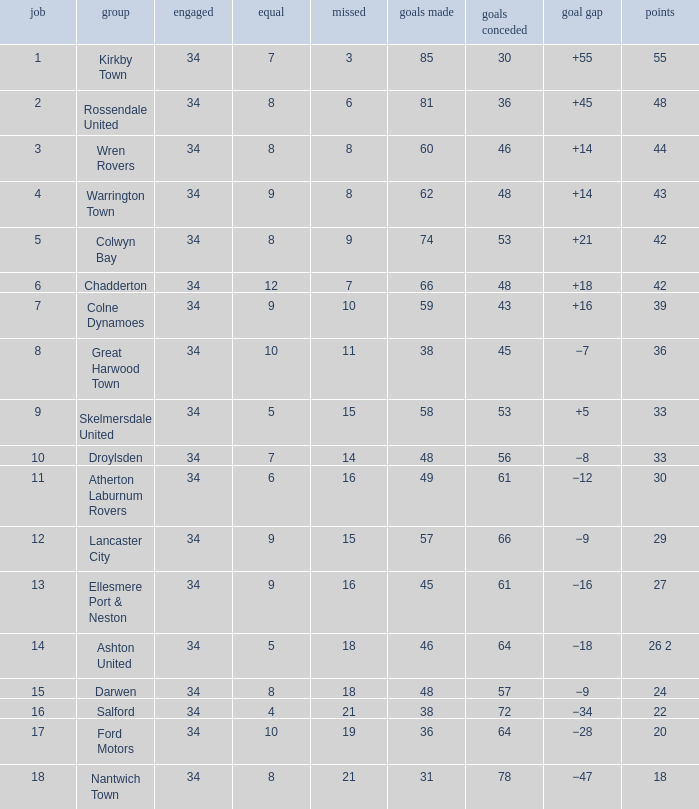What is the total number of positions when there are more than 48 goals against, 1 of 29 points are played, and less than 34 games have been played? 0.0. 